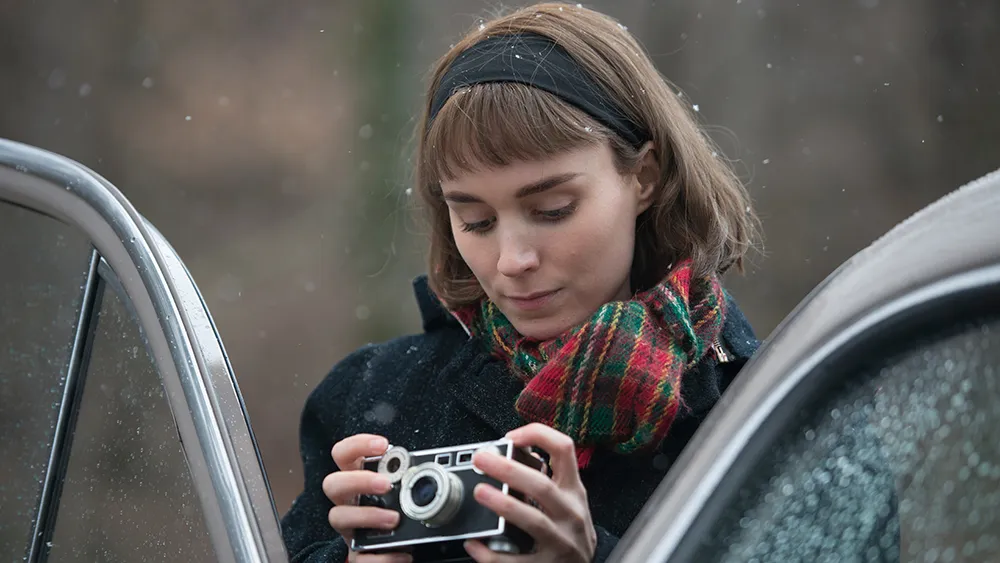What's the first thing she noticed this morning? The first thing she noticed this morning was the gentle patter of rain against her window, creating a soothing lullaby that beckoned her to explore the world outside. Peeking out, she saw the droplets forming delicate patterns on the glass, each one a tiny world of reflections. She felt an irresistible urge to capture the beauty of this rainy day, leading her to grab her camera and head out into the peaceful, damp forest. Imagine the last photo she took. Describe it in detail. The last photo she took was a striking close-up of a single, perfectly formed snowflake resting on a vibrant autumn leaf. The intricate patterns of the snowflake stood in stark contrast to the deep reds and oranges of the leaf, highlighting the delicate artistry of nature. The background was a soft blur of more leaves and a hint of the rain-speckled car, creating a bokeh effect that framed the snowflake and leaf in a halo of soft light. This photo encapsulated the fleeting beauty of the moment, a harmonious blend of autumn’s warmth and winter’s chill. 